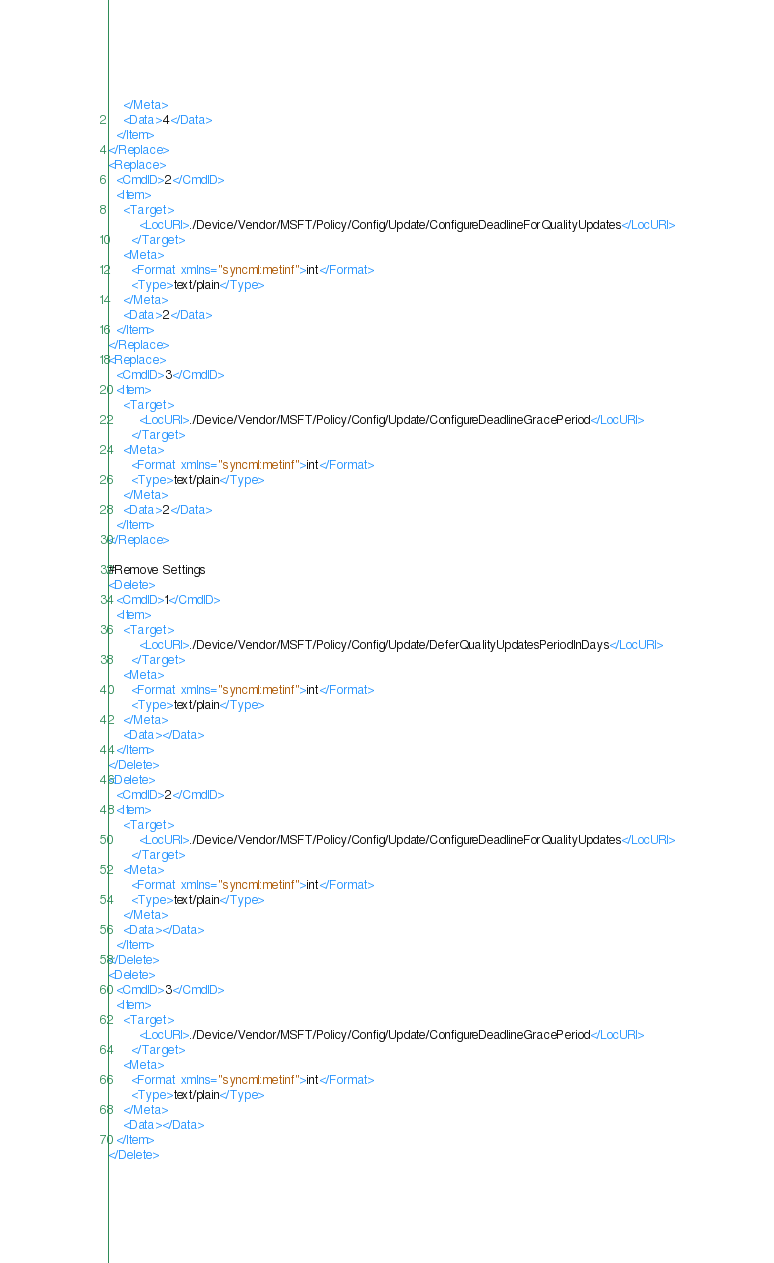<code> <loc_0><loc_0><loc_500><loc_500><_XML_>    </Meta>
    <Data>4</Data>
  </Item>
</Replace>
<Replace>
  <CmdID>2</CmdID>
  <Item>
    <Target>
        <LocURI>./Device/Vendor/MSFT/Policy/Config/Update/ConfigureDeadlineForQualityUpdates</LocURI>
      </Target>
    <Meta>
      <Format xmlns="syncml:metinf">int</Format>
      <Type>text/plain</Type>
    </Meta>
    <Data>2</Data>
  </Item>
</Replace>
<Replace>
  <CmdID>3</CmdID>
  <Item>
    <Target>
        <LocURI>./Device/Vendor/MSFT/Policy/Config/Update/ConfigureDeadlineGracePeriod</LocURI>
      </Target>
    <Meta>
      <Format xmlns="syncml:metinf">int</Format>
      <Type>text/plain</Type>
    </Meta>
    <Data>2</Data>
  </Item>
</Replace>

#Remove Settings
<Delete>
  <CmdID>1</CmdID>
  <Item>
    <Target>
        <LocURI>./Device/Vendor/MSFT/Policy/Config/Update/DeferQualityUpdatesPeriodInDays</LocURI>
      </Target>
    <Meta>
      <Format xmlns="syncml:metinf">int</Format>
      <Type>text/plain</Type>
    </Meta>
    <Data></Data>
  </Item>
</Delete>
<Delete>
  <CmdID>2</CmdID>
  <Item>
    <Target>
        <LocURI>./Device/Vendor/MSFT/Policy/Config/Update/ConfigureDeadlineForQualityUpdates</LocURI>
      </Target>
    <Meta>
      <Format xmlns="syncml:metinf">int</Format>
      <Type>text/plain</Type>
    </Meta>
    <Data></Data>
  </Item>
</Delete>
<Delete>
  <CmdID>3</CmdID>
  <Item>
    <Target>
        <LocURI>./Device/Vendor/MSFT/Policy/Config/Update/ConfigureDeadlineGracePeriod</LocURI>
      </Target>
    <Meta>
      <Format xmlns="syncml:metinf">int</Format>
      <Type>text/plain</Type>
    </Meta>
    <Data></Data>
  </Item>
</Delete></code> 